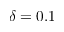Convert formula to latex. <formula><loc_0><loc_0><loc_500><loc_500>\delta = 0 . 1</formula> 